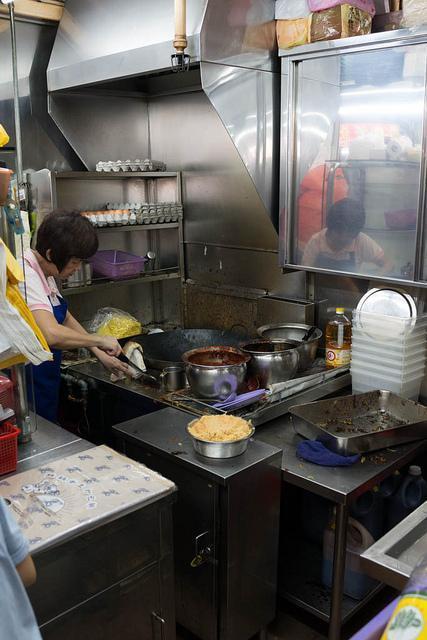How many bowls are visible?
Give a very brief answer. 3. How many people can you see?
Give a very brief answer. 2. 